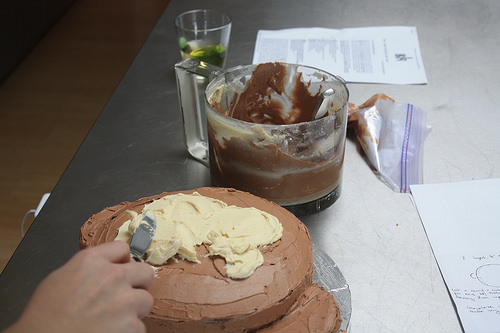<image>
Is the cup to the left of the frosting? No. The cup is not to the left of the frosting. From this viewpoint, they have a different horizontal relationship. Is the frosting behind the cake? Yes. From this viewpoint, the frosting is positioned behind the cake, with the cake partially or fully occluding the frosting. 